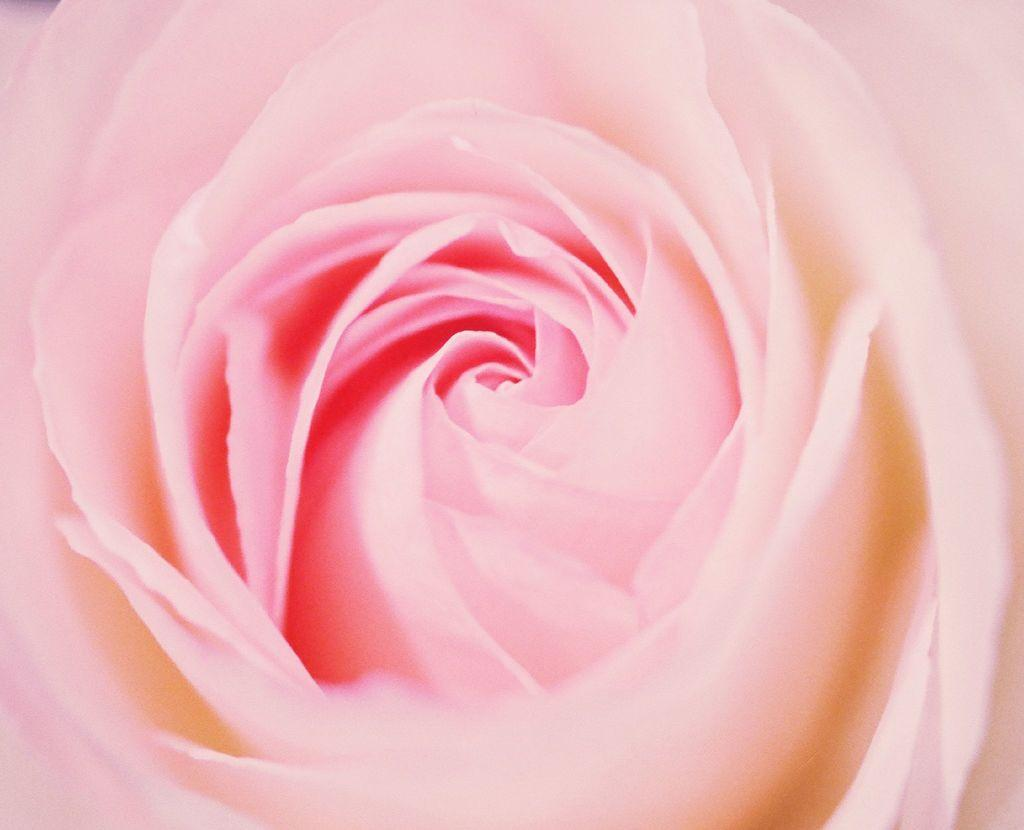What type of visual is the image? The image is a poster. What is the main subject of the poster? There is a flower depicted in the poster. How many beggars are visible in the poster? There are no beggars present in the poster; it features a flower. What type of pest can be seen crawling on the flower in the poster? There is no pest visible on the flower in the poster; it is a clean depiction of a flower. 